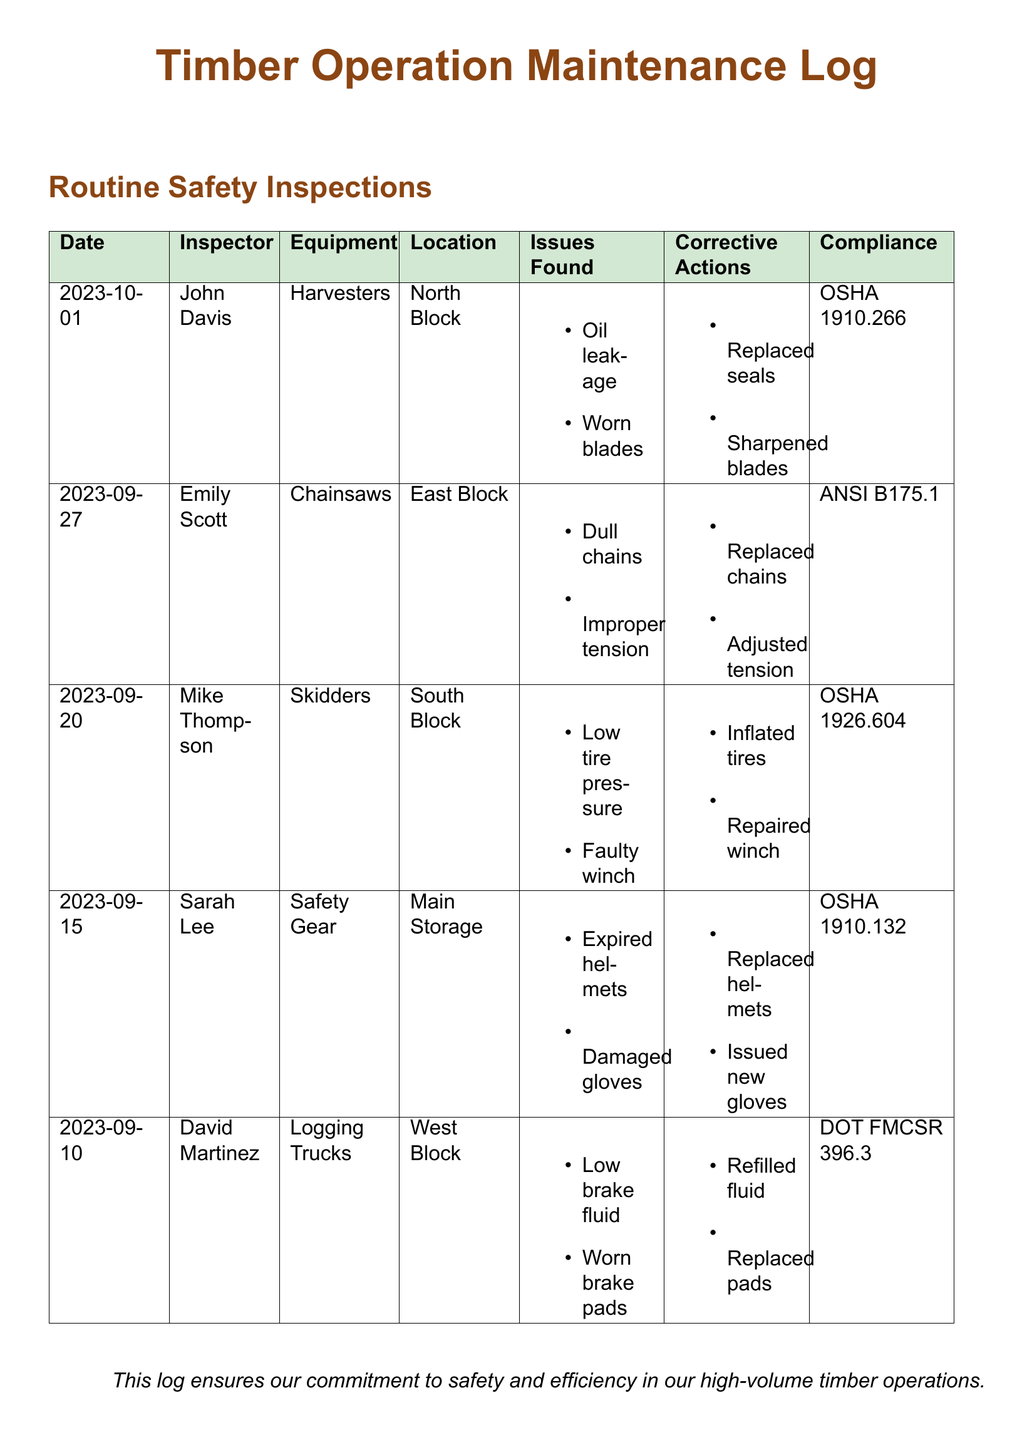What date was the last inspection performed? The last inspection noted in the log was on October 1, 2023.
Answer: October 1, 2023 Who inspected the chainsaws? The inspector for the chainsaws listed in the log is Emily Scott.
Answer: Emily Scott What issues were found for the skidders? The skidders had a low tire pressure and a faulty winch as issues noted in the log.
Answer: Low tire pressure, faulty winch What corrective action was taken for the worn blades? The corrective action taken for the worn blades was to sharpen them.
Answer: Sharpened blades Which safety regulation was cited for expired helmets? The safety regulation cited for the expired helmets is OSHA 1910.132.
Answer: OSHA 1910.132 Which equipment was inspected on September 27, 2023? The equipment inspected on that date was the chainsaws.
Answer: Chainsaws How many issues were documented for the logging trucks? Two issues were documented for the logging trucks: low brake fluid and worn brake pads.
Answer: Two issues What was the corrective action for the low tire pressure? The corrective action for low tire pressure was inflating the tires.
Answer: Inflated tires What is the overall focus of the maintenance log? The overall focus of the maintenance log is on safety and efficiency in timber operations.
Answer: Safety and efficiency 